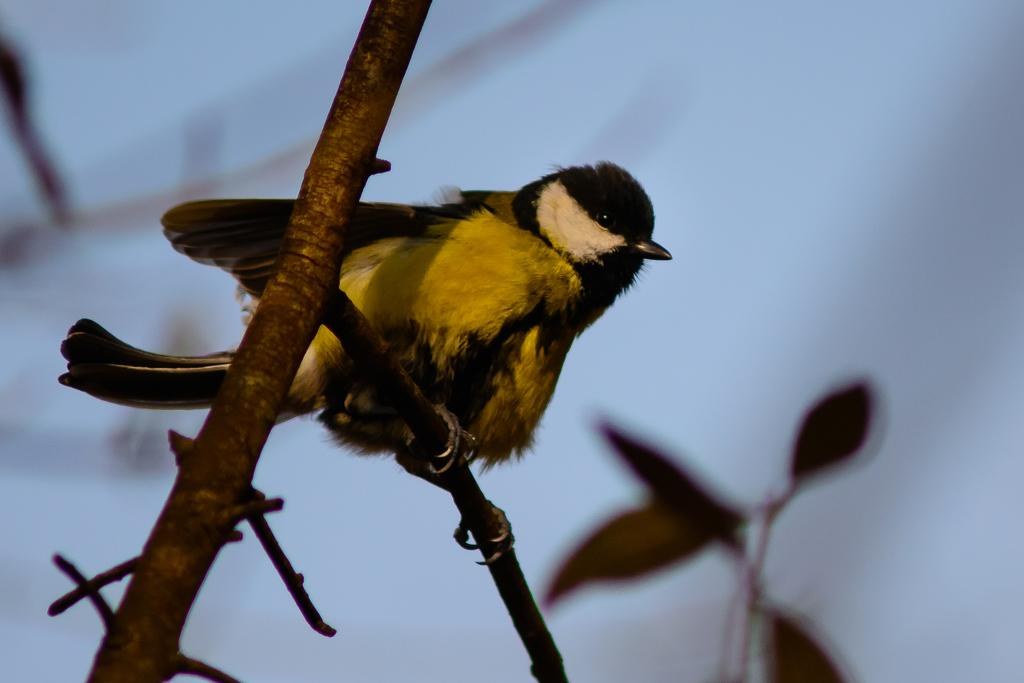What type of animal is in the image? There is a bird in the image. Where is the bird located in the image? The bird is on a stem stock in the image. What can be seen in the background of the image? The background of the image includes the sky. Can you see a kitten playing with a watch in the image? No, there is no kitten or watch present in the image. Is there any blood visible in the image? No, there is no blood visible in the image. 